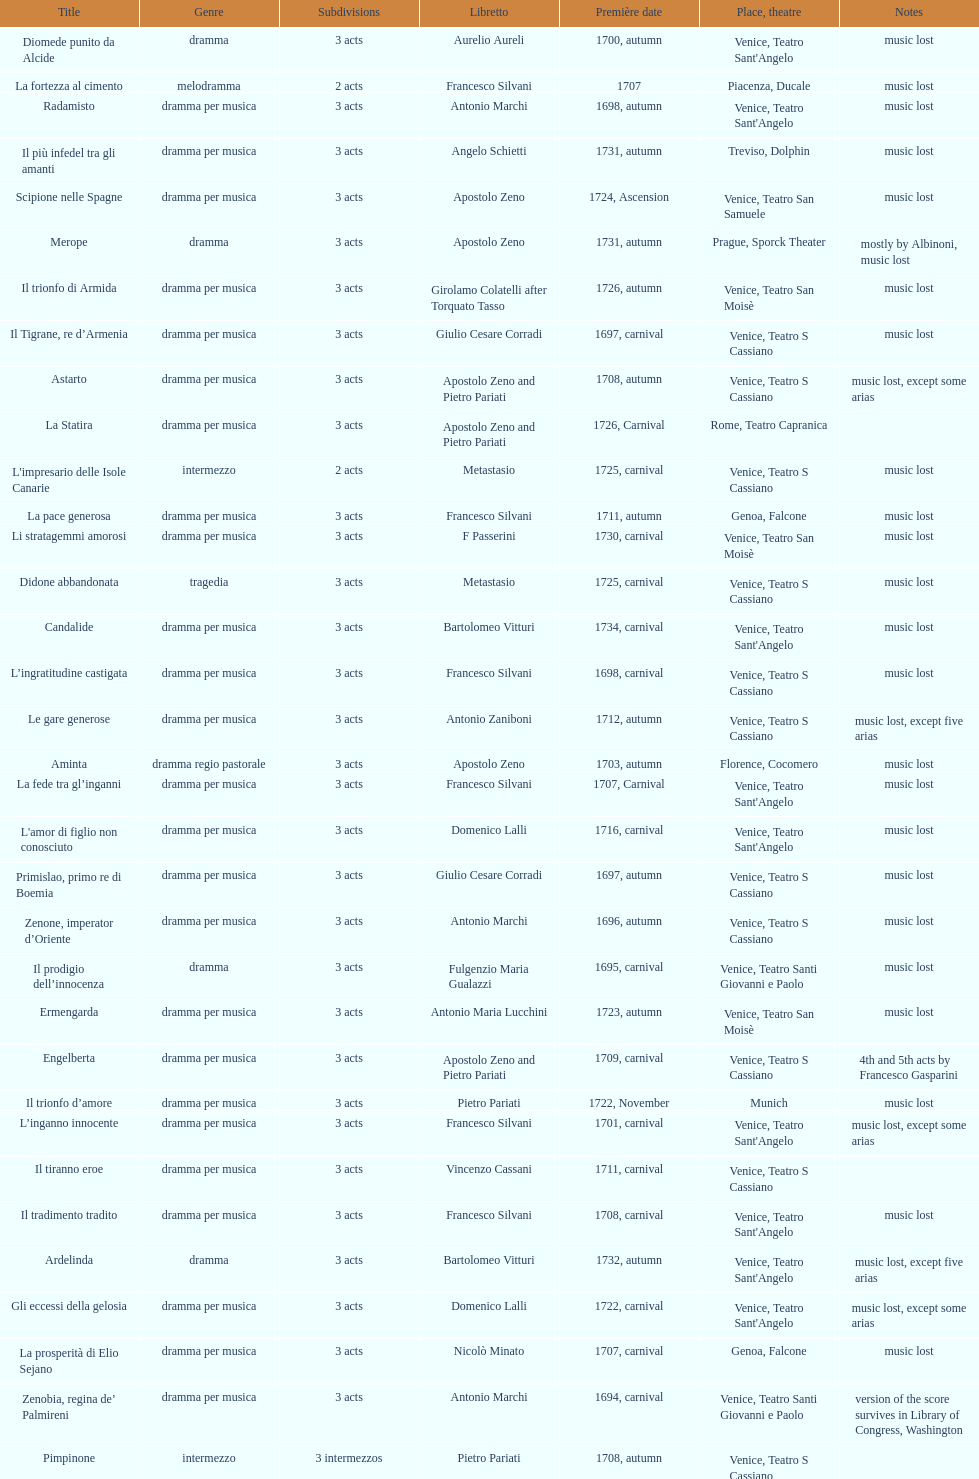Which was released earlier, artamene or merope? Merope. 